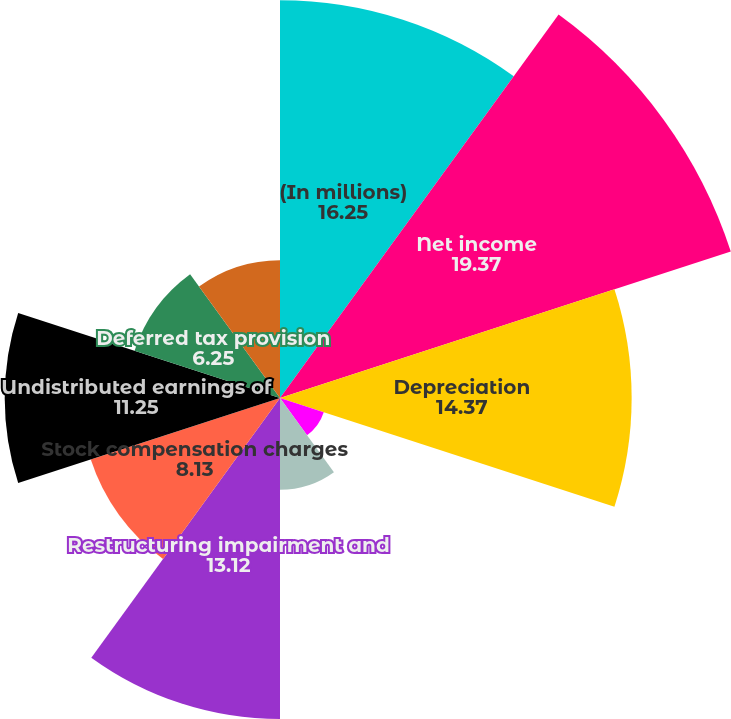<chart> <loc_0><loc_0><loc_500><loc_500><pie_chart><fcel>(In millions)<fcel>Net income<fcel>Depreciation<fcel>Amortization of purchased<fcel>Asbestos litigation charges<fcel>Restructuring impairment and<fcel>Stock compensation charges<fcel>Undistributed earnings of<fcel>Deferred tax provision<fcel>Restructuring payments<nl><fcel>16.25%<fcel>19.37%<fcel>14.37%<fcel>1.88%<fcel>3.75%<fcel>13.12%<fcel>8.13%<fcel>11.25%<fcel>6.25%<fcel>5.63%<nl></chart> 